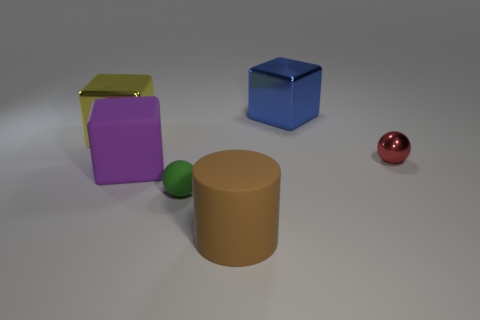Add 4 large purple things. How many objects exist? 10 Subtract all brown spheres. Subtract all yellow blocks. How many spheres are left? 2 Subtract all cylinders. How many objects are left? 5 Subtract 0 gray spheres. How many objects are left? 6 Subtract all purple metal objects. Subtract all big purple matte things. How many objects are left? 5 Add 1 red spheres. How many red spheres are left? 2 Add 3 spheres. How many spheres exist? 5 